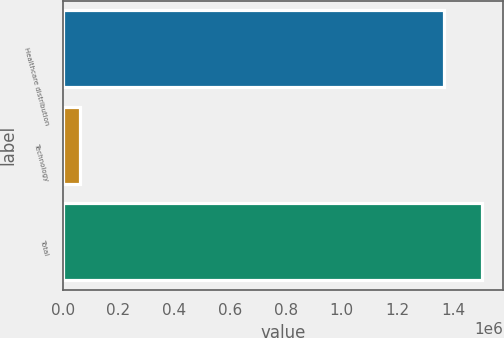Convert chart. <chart><loc_0><loc_0><loc_500><loc_500><bar_chart><fcel>Healthcare distribution<fcel>Technology<fcel>Total<nl><fcel>1.36811e+06<fcel>63661<fcel>1.50492e+06<nl></chart> 